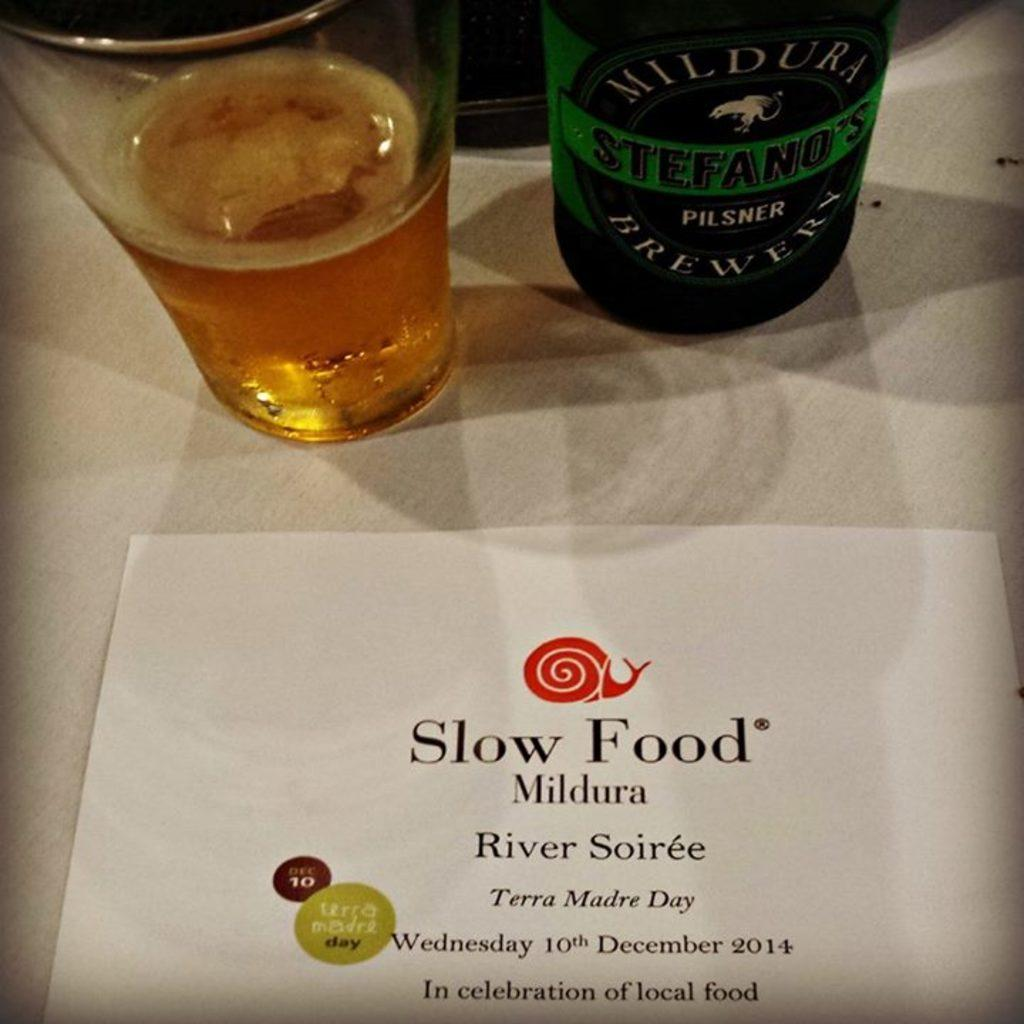<image>
Provide a brief description of the given image. A card reads Slow Food in front of a glass and bottle. 